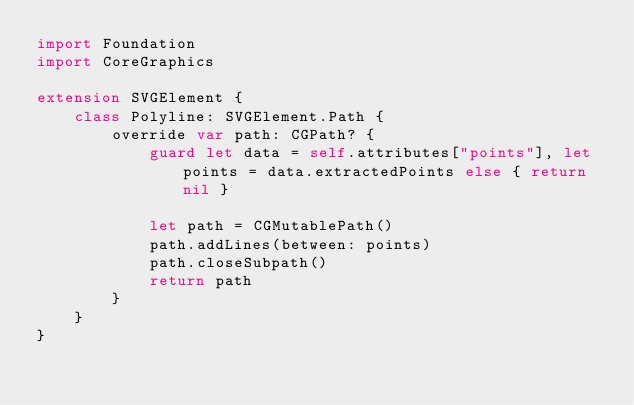<code> <loc_0><loc_0><loc_500><loc_500><_Swift_>import Foundation
import CoreGraphics

extension SVGElement {
	class Polyline: SVGElement.Path {
		override var path: CGPath? {
			guard let data = self.attributes["points"], let points = data.extractedPoints else { return nil }
			
			let path = CGMutablePath()
			path.addLines(between: points)
			path.closeSubpath()
			return path
		}
	}
}
</code> 